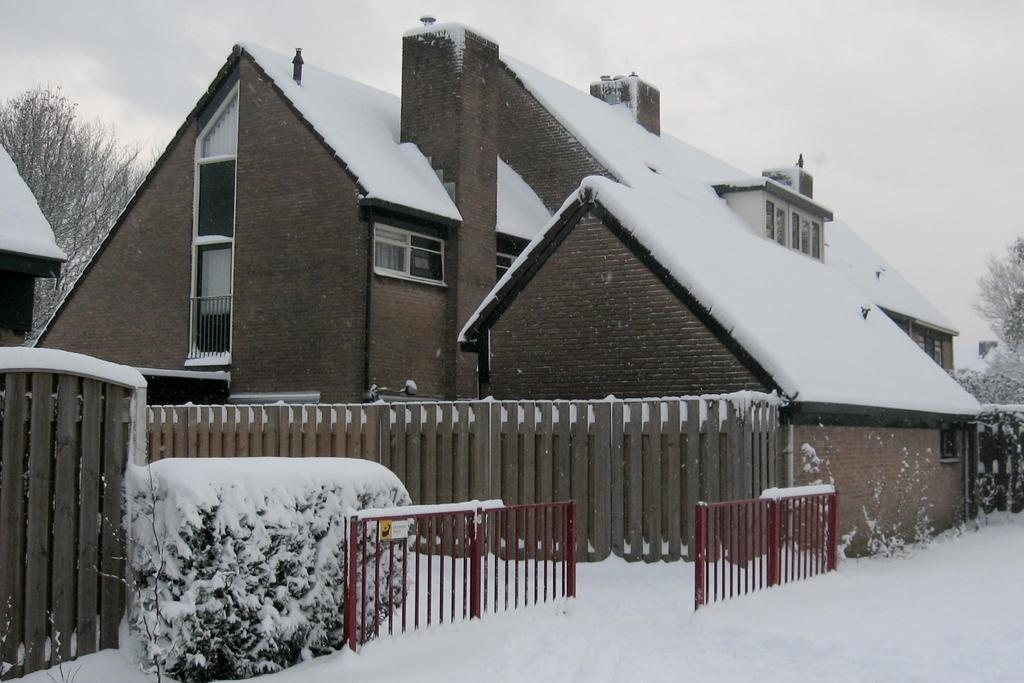What is the main feature of the image? There is a road in the image. What can be seen alongside the road? There is railing and a planter in the image. What type of fencing is present in the image? There is wooden fencing in the image. What can be seen in the background of the image? In the background, there are houses and trees covered with snow. What type of record can be seen spinning on a turntable in the image? There is no record or turntable present in the image. What kind of rock is visible in the image? There is no rock visible in the image. 